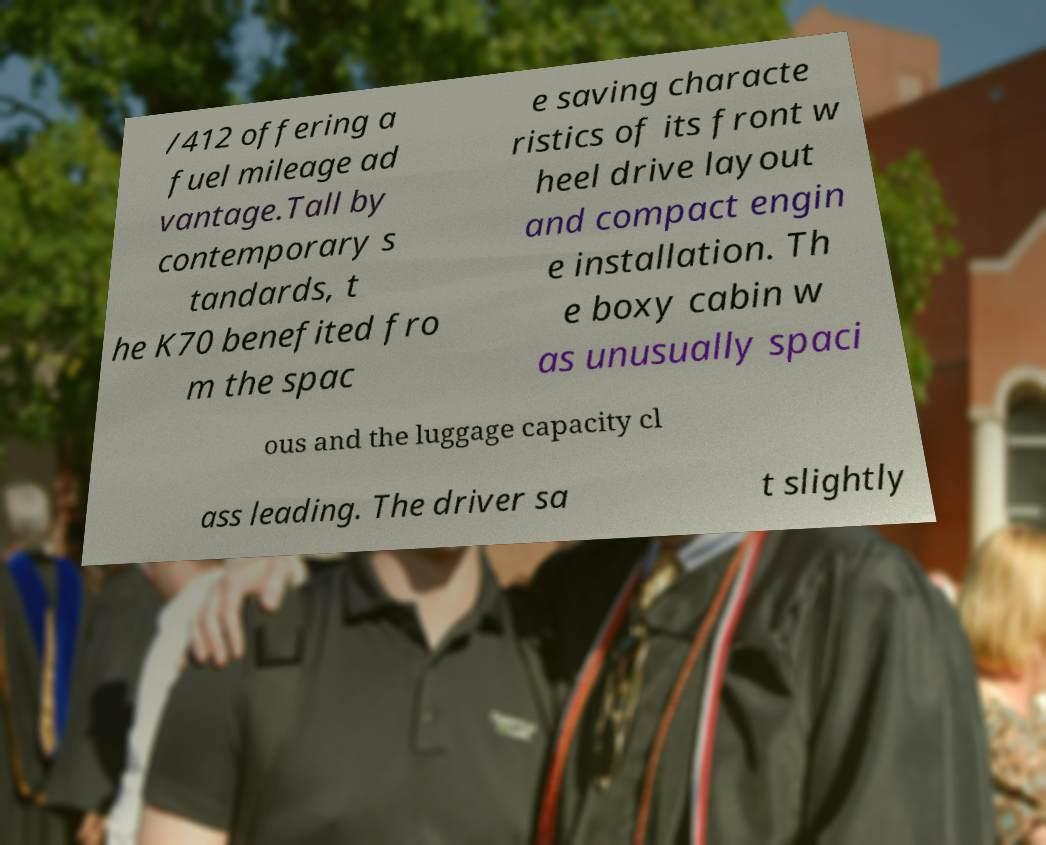Please read and relay the text visible in this image. What does it say? /412 offering a fuel mileage ad vantage.Tall by contemporary s tandards, t he K70 benefited fro m the spac e saving characte ristics of its front w heel drive layout and compact engin e installation. Th e boxy cabin w as unusually spaci ous and the luggage capacity cl ass leading. The driver sa t slightly 